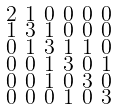Convert formula to latex. <formula><loc_0><loc_0><loc_500><loc_500>\begin{smallmatrix} 2 & 1 & 0 & 0 & 0 & 0 \\ 1 & 3 & 1 & 0 & 0 & 0 \\ 0 & 1 & 3 & 1 & 1 & 0 \\ 0 & 0 & 1 & 3 & 0 & 1 \\ 0 & 0 & 1 & 0 & 3 & 0 \\ 0 & 0 & 0 & 1 & 0 & 3 \end{smallmatrix}</formula> 